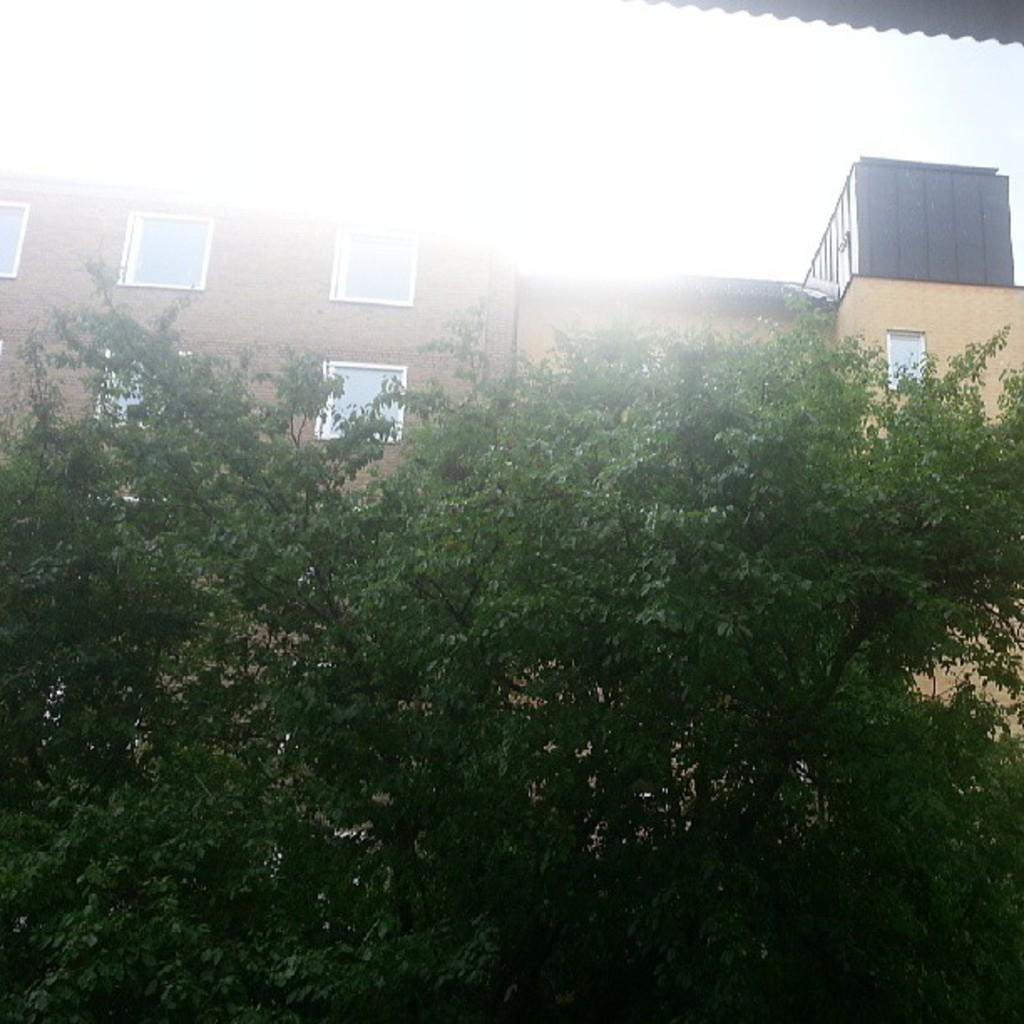How would you summarize this image in a sentence or two? In this image I can see there are trees at the back side there is a building with glass windows. 